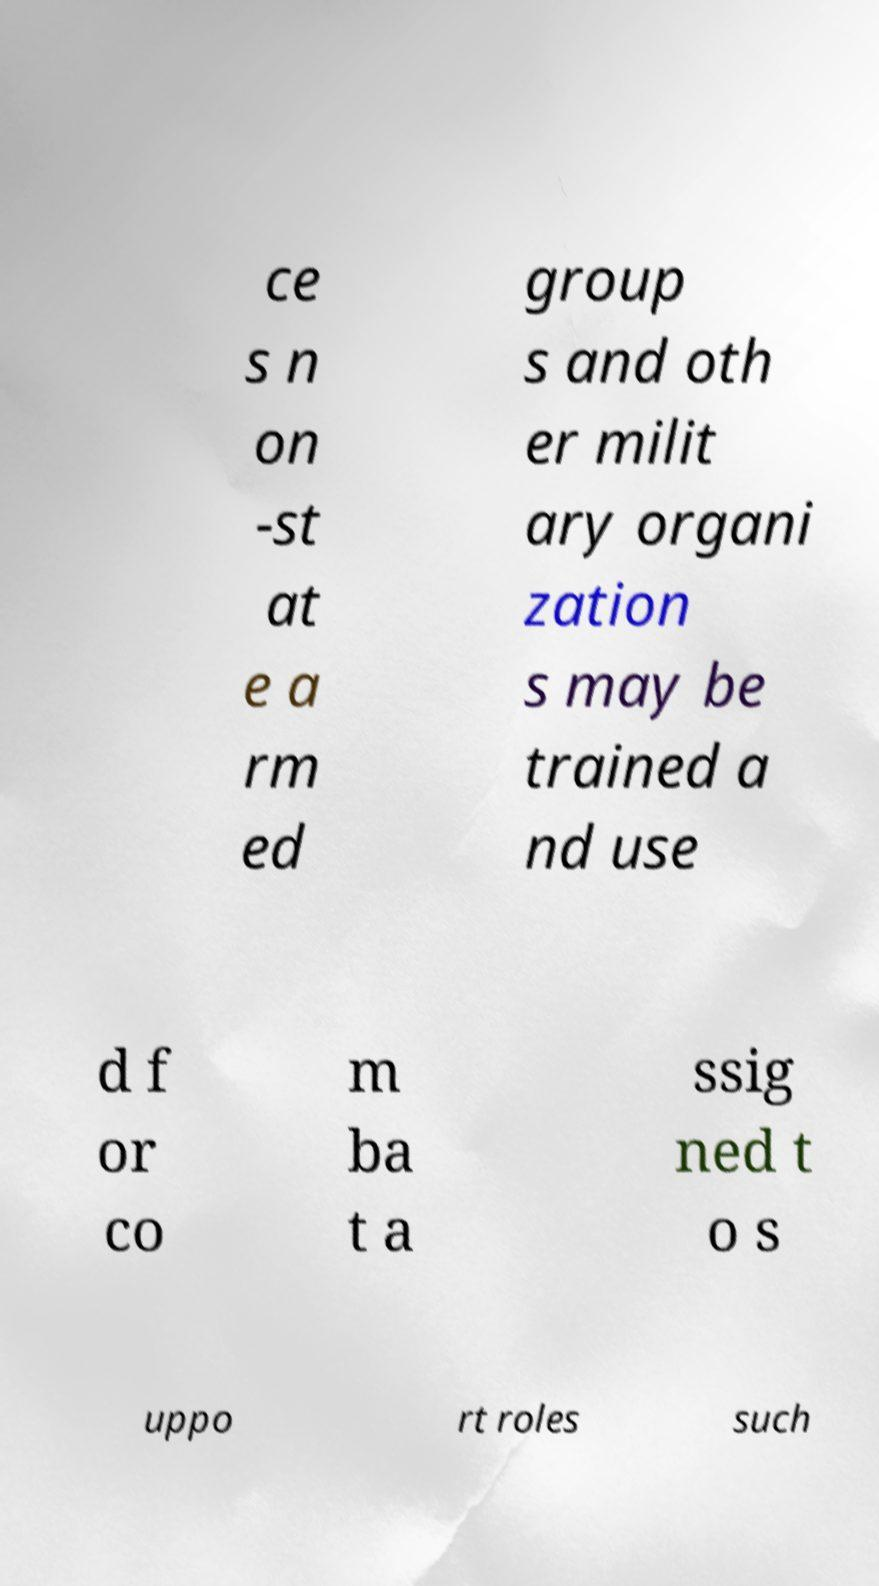For documentation purposes, I need the text within this image transcribed. Could you provide that? ce s n on -st at e a rm ed group s and oth er milit ary organi zation s may be trained a nd use d f or co m ba t a ssig ned t o s uppo rt roles such 